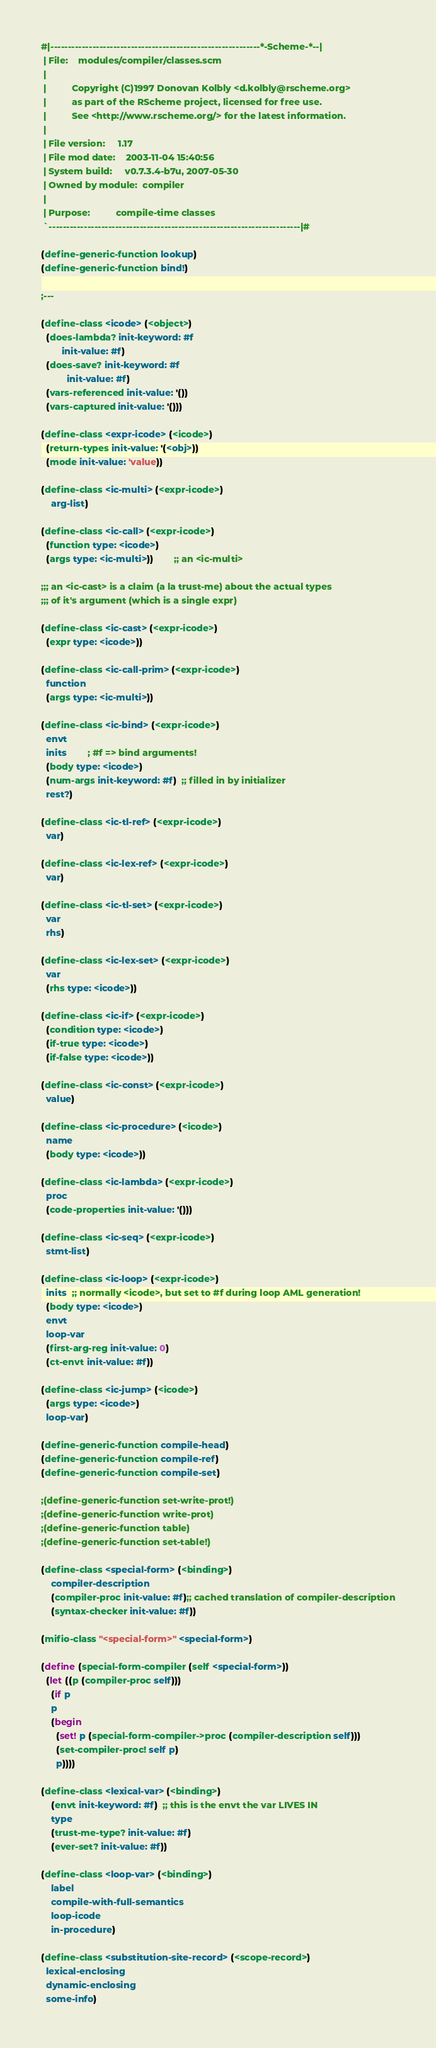Convert code to text. <code><loc_0><loc_0><loc_500><loc_500><_Scheme_>#|------------------------------------------------------------*-Scheme-*--|
 | File:    modules/compiler/classes.scm
 |
 |          Copyright (C)1997 Donovan Kolbly <d.kolbly@rscheme.org>
 |          as part of the RScheme project, licensed for free use.
 |          See <http://www.rscheme.org/> for the latest information.
 |
 | File version:     1.17
 | File mod date:    2003-11-04 15:40:56
 | System build:     v0.7.3.4-b7u, 2007-05-30
 | Owned by module:  compiler
 |
 | Purpose:          compile-time classes
 `------------------------------------------------------------------------|#

(define-generic-function lookup)
(define-generic-function bind!)

;---

(define-class <icode> (<object>)
  (does-lambda? init-keyword: #f
		init-value: #f)
  (does-save? init-keyword: #f
	      init-value: #f)
  (vars-referenced init-value: '())
  (vars-captured init-value: '()))

(define-class <expr-icode> (<icode>)
  (return-types init-value: '(<obj>))
  (mode init-value: 'value))

(define-class <ic-multi> (<expr-icode>)
    arg-list)

(define-class <ic-call> (<expr-icode>)
  (function type: <icode>)
  (args type: <ic-multi>))		;; an <ic-multi>

;;; an <ic-cast> is a claim (a la trust-me) about the actual types
;;; of it's argument (which is a single expr)

(define-class <ic-cast> (<expr-icode>)
  (expr type: <icode>))

(define-class <ic-call-prim> (<expr-icode>)
  function
  (args type: <ic-multi>))

(define-class <ic-bind> (<expr-icode>)
  envt
  inits		; #f => bind arguments!
  (body type: <icode>)
  (num-args init-keyword: #f)  ;; filled in by initializer
  rest?)

(define-class <ic-tl-ref> (<expr-icode>)
  var)

(define-class <ic-lex-ref> (<expr-icode>)
  var)
    
(define-class <ic-tl-set> (<expr-icode>)
  var
  rhs)

(define-class <ic-lex-set> (<expr-icode>)
  var
  (rhs type: <icode>))

(define-class <ic-if> (<expr-icode>)
  (condition type: <icode>)
  (if-true type: <icode>)
  (if-false type: <icode>))

(define-class <ic-const> (<expr-icode>)
  value)

(define-class <ic-procedure> (<icode>)
  name
  (body type: <icode>))

(define-class <ic-lambda> (<expr-icode>)
  proc
  (code-properties init-value: '()))

(define-class <ic-seq> (<expr-icode>)
  stmt-list)

(define-class <ic-loop> (<expr-icode>)
  inits  ;; normally <icode>, but set to #f during loop AML generation!
  (body type: <icode>)
  envt
  loop-var
  (first-arg-reg init-value: 0)
  (ct-envt init-value: #f))

(define-class <ic-jump> (<icode>)
  (args type: <icode>)
  loop-var)

(define-generic-function compile-head)
(define-generic-function compile-ref)
(define-generic-function compile-set)

;(define-generic-function set-write-prot!)
;(define-generic-function write-prot)
;(define-generic-function table)
;(define-generic-function set-table!)

(define-class <special-form> (<binding>)
    compiler-description
    (compiler-proc init-value: #f);; cached translation of compiler-description
    (syntax-checker init-value: #f))

(mifio-class "<special-form>" <special-form>)

(define (special-form-compiler (self <special-form>))
  (let ((p (compiler-proc self)))
    (if p
	p
	(begin
	  (set! p (special-form-compiler->proc (compiler-description self)))
	  (set-compiler-proc! self p)
	  p))))

(define-class <lexical-var> (<binding>)
    (envt init-keyword: #f)  ;; this is the envt the var LIVES IN
    type
    (trust-me-type? init-value: #f)
    (ever-set? init-value: #f))

(define-class <loop-var> (<binding>)
    label
    compile-with-full-semantics
    loop-icode
    in-procedure)

(define-class <substitution-site-record> (<scope-record>)
  lexical-enclosing
  dynamic-enclosing
  some-info)
</code> 